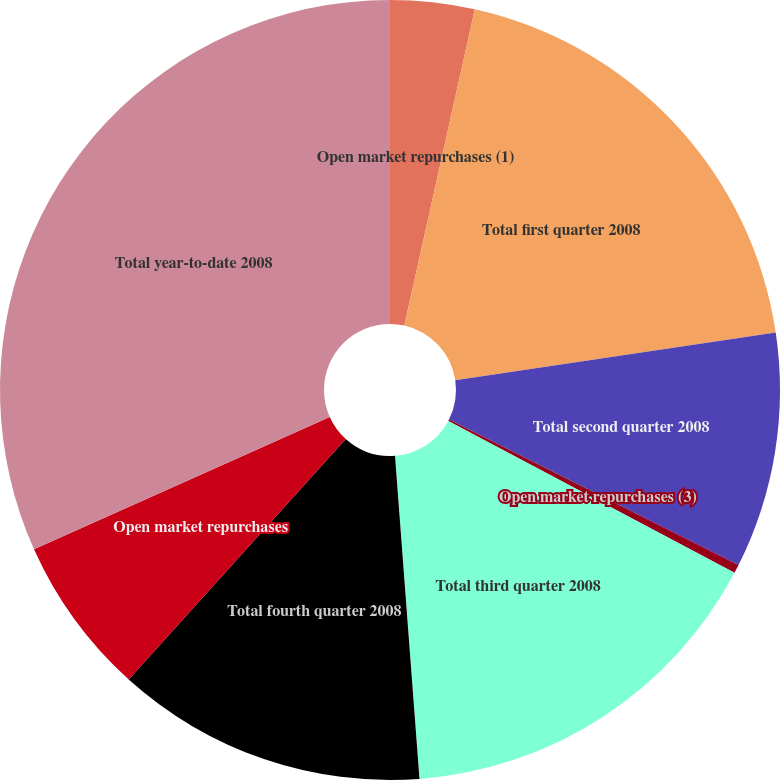Convert chart. <chart><loc_0><loc_0><loc_500><loc_500><pie_chart><fcel>Open market repurchases (1)<fcel>Total first quarter 2008<fcel>Total second quarter 2008<fcel>Open market repurchases (3)<fcel>Total third quarter 2008<fcel>Total fourth quarter 2008<fcel>Open market repurchases<fcel>Total year-to-date 2008<nl><fcel>3.49%<fcel>19.16%<fcel>9.76%<fcel>0.36%<fcel>16.03%<fcel>12.89%<fcel>6.62%<fcel>31.7%<nl></chart> 